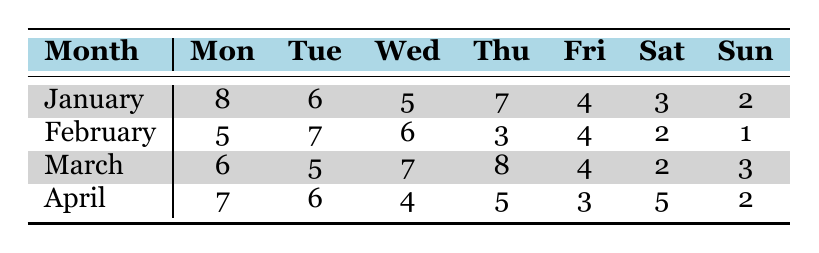What is the rainfall frequency for Wednesdays in March? The table shows that for March, the rainfall frequency on Wednesday is 7.
Answer: 7 Which month has the highest rainfall frequency on Fridays? By examining the table, we see that March has a frequency of 4 for Fridays, while January has 4, April has 3, and February has 4. However, there is no higher number than 4 for Friday across the months, indicating it's a tie.
Answer: 4 Is it true that Sunday has the lowest rainfall frequency in February? The table indicates that Sunday in February has a rainfall frequency of 1, which is lower than all other weekdays in that month: 5, 7, 6, 3, and 4 for Monday, Tuesday, Wednesday, Thursday, and Friday respectively. Thus, the statement is true.
Answer: Yes What is the total rainfall frequency for Saturdays in January and April combined? From the table, the rainfall frequency for Saturday in January is 3 and in April is 5. Adding these values: 3 + 5 = 8.
Answer: 8 Which weekday in January has the highest rainfall frequency? Referring to the table, Monday has the highest rainfall frequency in January at 8, compared to all other weekdays in that month.
Answer: 8 What is the average rainfall frequency for Thursdays across all months? The rainfall frequency for Thursdays in January, February, March, and April is 7, 3, 8, and 5, respectively. Summing these yields: 7 + 3 + 8 + 5 = 23. There are 4 data points, so the average is 23 / 4 = 5.75.
Answer: 5.75 Are there any months where rainfall frequency on a Saturday is higher than for any other day? From the table, April has a Saturday frequency of 5, which is equal to its Friday frequency but less than its Monday frequency of 7 and Tuesday of 6. Therefore, no month has a Saturday frequency higher than any other day in the same month.
Answer: No What is the difference in rainfall frequency between Mondays and Fridays in January? The rainfall frequency for Mondays in January is 8 and for Fridays is 4. The difference is calculated as 8 - 4 = 4.
Answer: 4 